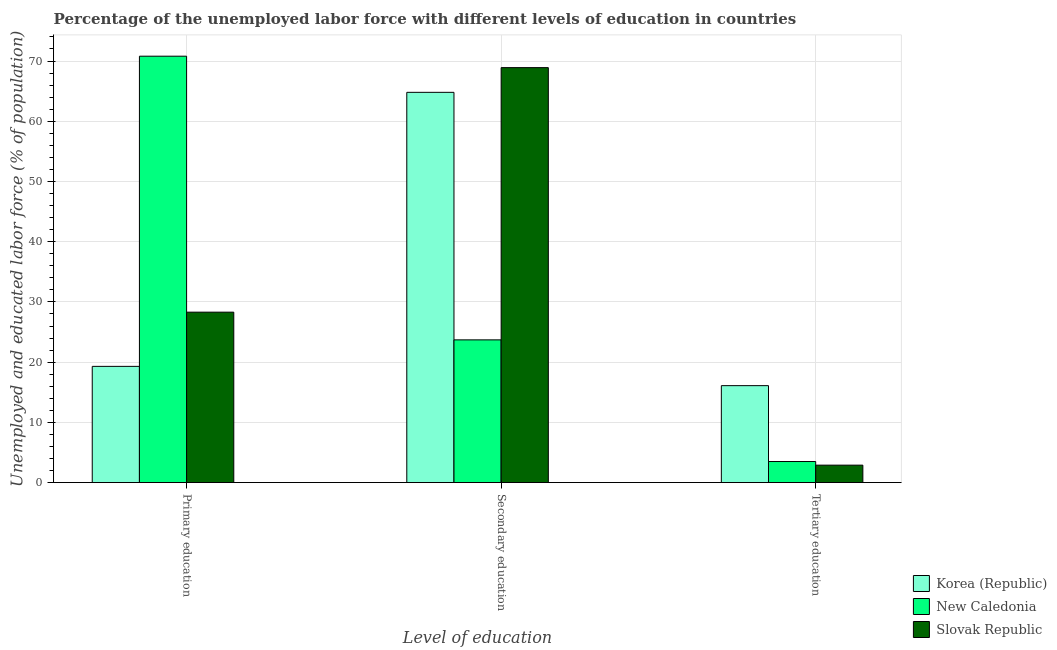Are the number of bars on each tick of the X-axis equal?
Make the answer very short. Yes. How many bars are there on the 1st tick from the left?
Your answer should be very brief. 3. How many bars are there on the 1st tick from the right?
Provide a short and direct response. 3. What is the percentage of labor force who received primary education in New Caledonia?
Give a very brief answer. 70.8. Across all countries, what is the maximum percentage of labor force who received secondary education?
Your answer should be very brief. 68.9. Across all countries, what is the minimum percentage of labor force who received tertiary education?
Provide a succinct answer. 2.9. In which country was the percentage of labor force who received tertiary education maximum?
Offer a terse response. Korea (Republic). In which country was the percentage of labor force who received secondary education minimum?
Give a very brief answer. New Caledonia. What is the total percentage of labor force who received primary education in the graph?
Your response must be concise. 118.4. What is the difference between the percentage of labor force who received tertiary education in Korea (Republic) and that in New Caledonia?
Make the answer very short. 12.6. What is the difference between the percentage of labor force who received secondary education in Slovak Republic and the percentage of labor force who received primary education in Korea (Republic)?
Make the answer very short. 49.6. What is the average percentage of labor force who received primary education per country?
Provide a succinct answer. 39.47. What is the difference between the percentage of labor force who received primary education and percentage of labor force who received secondary education in Korea (Republic)?
Provide a succinct answer. -45.5. In how many countries, is the percentage of labor force who received primary education greater than 58 %?
Provide a short and direct response. 1. What is the ratio of the percentage of labor force who received tertiary education in Korea (Republic) to that in Slovak Republic?
Offer a terse response. 5.55. Is the percentage of labor force who received primary education in Slovak Republic less than that in Korea (Republic)?
Your response must be concise. No. Is the difference between the percentage of labor force who received secondary education in Korea (Republic) and Slovak Republic greater than the difference between the percentage of labor force who received primary education in Korea (Republic) and Slovak Republic?
Your response must be concise. Yes. What is the difference between the highest and the second highest percentage of labor force who received primary education?
Ensure brevity in your answer.  42.5. What is the difference between the highest and the lowest percentage of labor force who received secondary education?
Give a very brief answer. 45.2. In how many countries, is the percentage of labor force who received tertiary education greater than the average percentage of labor force who received tertiary education taken over all countries?
Offer a very short reply. 1. Is the sum of the percentage of labor force who received primary education in Korea (Republic) and New Caledonia greater than the maximum percentage of labor force who received secondary education across all countries?
Offer a terse response. Yes. What does the 2nd bar from the left in Secondary education represents?
Provide a short and direct response. New Caledonia. Are all the bars in the graph horizontal?
Offer a very short reply. No. How many countries are there in the graph?
Make the answer very short. 3. What is the title of the graph?
Offer a very short reply. Percentage of the unemployed labor force with different levels of education in countries. Does "Bahamas" appear as one of the legend labels in the graph?
Give a very brief answer. No. What is the label or title of the X-axis?
Give a very brief answer. Level of education. What is the label or title of the Y-axis?
Offer a very short reply. Unemployed and educated labor force (% of population). What is the Unemployed and educated labor force (% of population) of Korea (Republic) in Primary education?
Provide a succinct answer. 19.3. What is the Unemployed and educated labor force (% of population) of New Caledonia in Primary education?
Your response must be concise. 70.8. What is the Unemployed and educated labor force (% of population) in Slovak Republic in Primary education?
Your answer should be compact. 28.3. What is the Unemployed and educated labor force (% of population) in Korea (Republic) in Secondary education?
Make the answer very short. 64.8. What is the Unemployed and educated labor force (% of population) in New Caledonia in Secondary education?
Offer a terse response. 23.7. What is the Unemployed and educated labor force (% of population) of Slovak Republic in Secondary education?
Keep it short and to the point. 68.9. What is the Unemployed and educated labor force (% of population) in Korea (Republic) in Tertiary education?
Your response must be concise. 16.1. What is the Unemployed and educated labor force (% of population) in Slovak Republic in Tertiary education?
Your response must be concise. 2.9. Across all Level of education, what is the maximum Unemployed and educated labor force (% of population) in Korea (Republic)?
Offer a terse response. 64.8. Across all Level of education, what is the maximum Unemployed and educated labor force (% of population) of New Caledonia?
Provide a succinct answer. 70.8. Across all Level of education, what is the maximum Unemployed and educated labor force (% of population) in Slovak Republic?
Provide a succinct answer. 68.9. Across all Level of education, what is the minimum Unemployed and educated labor force (% of population) in Korea (Republic)?
Keep it short and to the point. 16.1. Across all Level of education, what is the minimum Unemployed and educated labor force (% of population) of New Caledonia?
Ensure brevity in your answer.  3.5. Across all Level of education, what is the minimum Unemployed and educated labor force (% of population) in Slovak Republic?
Make the answer very short. 2.9. What is the total Unemployed and educated labor force (% of population) of Korea (Republic) in the graph?
Provide a short and direct response. 100.2. What is the total Unemployed and educated labor force (% of population) of New Caledonia in the graph?
Offer a very short reply. 98. What is the total Unemployed and educated labor force (% of population) of Slovak Republic in the graph?
Your response must be concise. 100.1. What is the difference between the Unemployed and educated labor force (% of population) of Korea (Republic) in Primary education and that in Secondary education?
Offer a terse response. -45.5. What is the difference between the Unemployed and educated labor force (% of population) in New Caledonia in Primary education and that in Secondary education?
Your response must be concise. 47.1. What is the difference between the Unemployed and educated labor force (% of population) in Slovak Republic in Primary education and that in Secondary education?
Your answer should be compact. -40.6. What is the difference between the Unemployed and educated labor force (% of population) in Korea (Republic) in Primary education and that in Tertiary education?
Your answer should be very brief. 3.2. What is the difference between the Unemployed and educated labor force (% of population) of New Caledonia in Primary education and that in Tertiary education?
Your response must be concise. 67.3. What is the difference between the Unemployed and educated labor force (% of population) of Slovak Republic in Primary education and that in Tertiary education?
Keep it short and to the point. 25.4. What is the difference between the Unemployed and educated labor force (% of population) in Korea (Republic) in Secondary education and that in Tertiary education?
Your answer should be compact. 48.7. What is the difference between the Unemployed and educated labor force (% of population) of New Caledonia in Secondary education and that in Tertiary education?
Offer a terse response. 20.2. What is the difference between the Unemployed and educated labor force (% of population) in Korea (Republic) in Primary education and the Unemployed and educated labor force (% of population) in Slovak Republic in Secondary education?
Offer a terse response. -49.6. What is the difference between the Unemployed and educated labor force (% of population) in Korea (Republic) in Primary education and the Unemployed and educated labor force (% of population) in Slovak Republic in Tertiary education?
Your response must be concise. 16.4. What is the difference between the Unemployed and educated labor force (% of population) of New Caledonia in Primary education and the Unemployed and educated labor force (% of population) of Slovak Republic in Tertiary education?
Keep it short and to the point. 67.9. What is the difference between the Unemployed and educated labor force (% of population) of Korea (Republic) in Secondary education and the Unemployed and educated labor force (% of population) of New Caledonia in Tertiary education?
Offer a terse response. 61.3. What is the difference between the Unemployed and educated labor force (% of population) of Korea (Republic) in Secondary education and the Unemployed and educated labor force (% of population) of Slovak Republic in Tertiary education?
Your answer should be compact. 61.9. What is the difference between the Unemployed and educated labor force (% of population) in New Caledonia in Secondary education and the Unemployed and educated labor force (% of population) in Slovak Republic in Tertiary education?
Provide a succinct answer. 20.8. What is the average Unemployed and educated labor force (% of population) in Korea (Republic) per Level of education?
Your response must be concise. 33.4. What is the average Unemployed and educated labor force (% of population) in New Caledonia per Level of education?
Give a very brief answer. 32.67. What is the average Unemployed and educated labor force (% of population) of Slovak Republic per Level of education?
Make the answer very short. 33.37. What is the difference between the Unemployed and educated labor force (% of population) of Korea (Republic) and Unemployed and educated labor force (% of population) of New Caledonia in Primary education?
Offer a terse response. -51.5. What is the difference between the Unemployed and educated labor force (% of population) in Korea (Republic) and Unemployed and educated labor force (% of population) in Slovak Republic in Primary education?
Make the answer very short. -9. What is the difference between the Unemployed and educated labor force (% of population) in New Caledonia and Unemployed and educated labor force (% of population) in Slovak Republic in Primary education?
Offer a very short reply. 42.5. What is the difference between the Unemployed and educated labor force (% of population) in Korea (Republic) and Unemployed and educated labor force (% of population) in New Caledonia in Secondary education?
Give a very brief answer. 41.1. What is the difference between the Unemployed and educated labor force (% of population) of New Caledonia and Unemployed and educated labor force (% of population) of Slovak Republic in Secondary education?
Make the answer very short. -45.2. What is the difference between the Unemployed and educated labor force (% of population) in Korea (Republic) and Unemployed and educated labor force (% of population) in New Caledonia in Tertiary education?
Provide a succinct answer. 12.6. What is the difference between the Unemployed and educated labor force (% of population) in New Caledonia and Unemployed and educated labor force (% of population) in Slovak Republic in Tertiary education?
Give a very brief answer. 0.6. What is the ratio of the Unemployed and educated labor force (% of population) of Korea (Republic) in Primary education to that in Secondary education?
Offer a very short reply. 0.3. What is the ratio of the Unemployed and educated labor force (% of population) in New Caledonia in Primary education to that in Secondary education?
Your answer should be very brief. 2.99. What is the ratio of the Unemployed and educated labor force (% of population) in Slovak Republic in Primary education to that in Secondary education?
Provide a short and direct response. 0.41. What is the ratio of the Unemployed and educated labor force (% of population) of Korea (Republic) in Primary education to that in Tertiary education?
Your answer should be compact. 1.2. What is the ratio of the Unemployed and educated labor force (% of population) of New Caledonia in Primary education to that in Tertiary education?
Your response must be concise. 20.23. What is the ratio of the Unemployed and educated labor force (% of population) in Slovak Republic in Primary education to that in Tertiary education?
Provide a succinct answer. 9.76. What is the ratio of the Unemployed and educated labor force (% of population) in Korea (Republic) in Secondary education to that in Tertiary education?
Offer a very short reply. 4.02. What is the ratio of the Unemployed and educated labor force (% of population) in New Caledonia in Secondary education to that in Tertiary education?
Your response must be concise. 6.77. What is the ratio of the Unemployed and educated labor force (% of population) of Slovak Republic in Secondary education to that in Tertiary education?
Your answer should be compact. 23.76. What is the difference between the highest and the second highest Unemployed and educated labor force (% of population) of Korea (Republic)?
Your response must be concise. 45.5. What is the difference between the highest and the second highest Unemployed and educated labor force (% of population) of New Caledonia?
Provide a succinct answer. 47.1. What is the difference between the highest and the second highest Unemployed and educated labor force (% of population) in Slovak Republic?
Your answer should be compact. 40.6. What is the difference between the highest and the lowest Unemployed and educated labor force (% of population) of Korea (Republic)?
Your response must be concise. 48.7. What is the difference between the highest and the lowest Unemployed and educated labor force (% of population) of New Caledonia?
Ensure brevity in your answer.  67.3. 